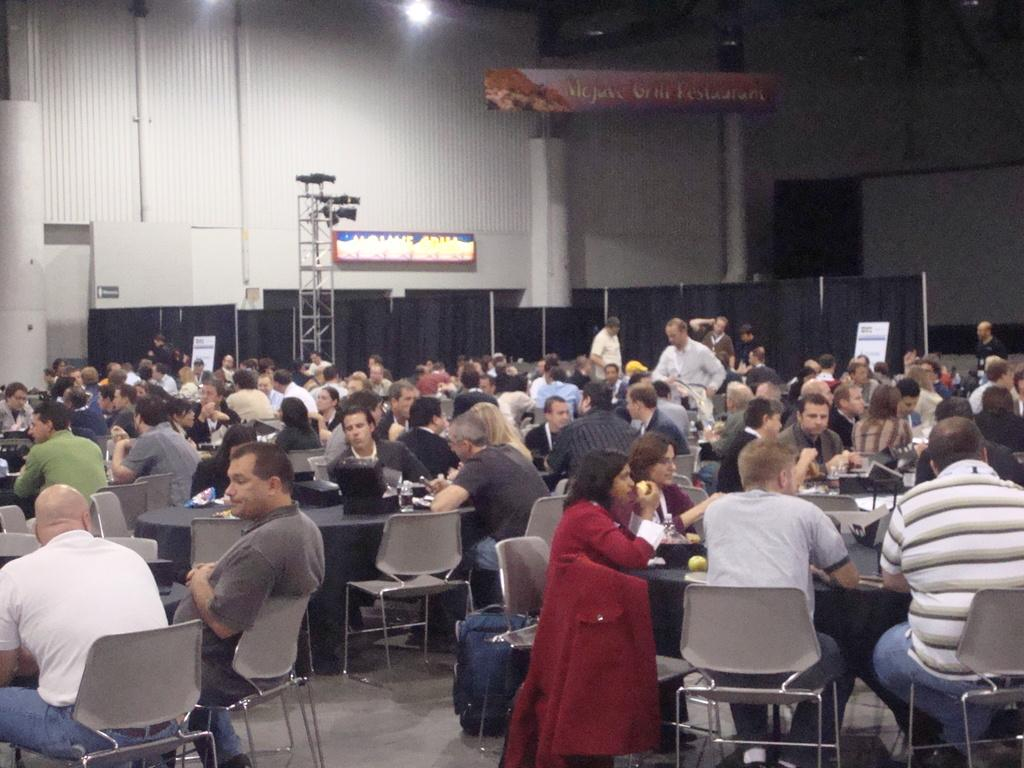How are the people in the image arranged? The people are sitting on chairs arranged around a table. What can be seen in the background of the image? In the background of the image, there is a pole, a hoarding, a light, a pillar, and a wall. What might the people be doing while sitting around the table? It is not clear from the image what the people are doing, but they could be having a meeting, eating a meal, or engaging in a group activity. Can you see any holes in the image? There are no holes visible in the image. Is there a hen present in the image? There is no hen present in the image. 